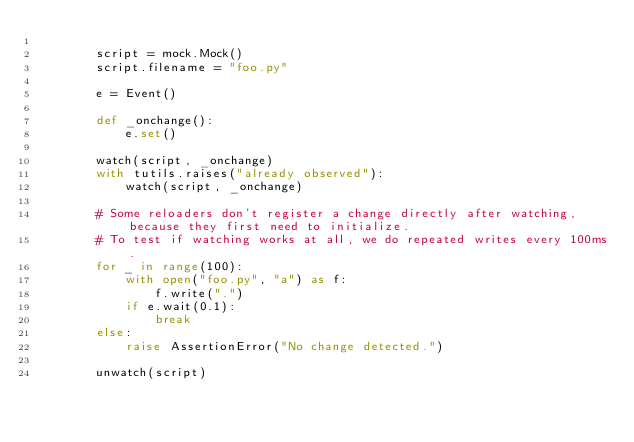<code> <loc_0><loc_0><loc_500><loc_500><_Python_>
        script = mock.Mock()
        script.filename = "foo.py"

        e = Event()

        def _onchange():
            e.set()

        watch(script, _onchange)
        with tutils.raises("already observed"):
            watch(script, _onchange)

        # Some reloaders don't register a change directly after watching, because they first need to initialize.
        # To test if watching works at all, we do repeated writes every 100ms.
        for _ in range(100):
            with open("foo.py", "a") as f:
                f.write(".")
            if e.wait(0.1):
                break
        else:
            raise AssertionError("No change detected.")

        unwatch(script)
</code> 